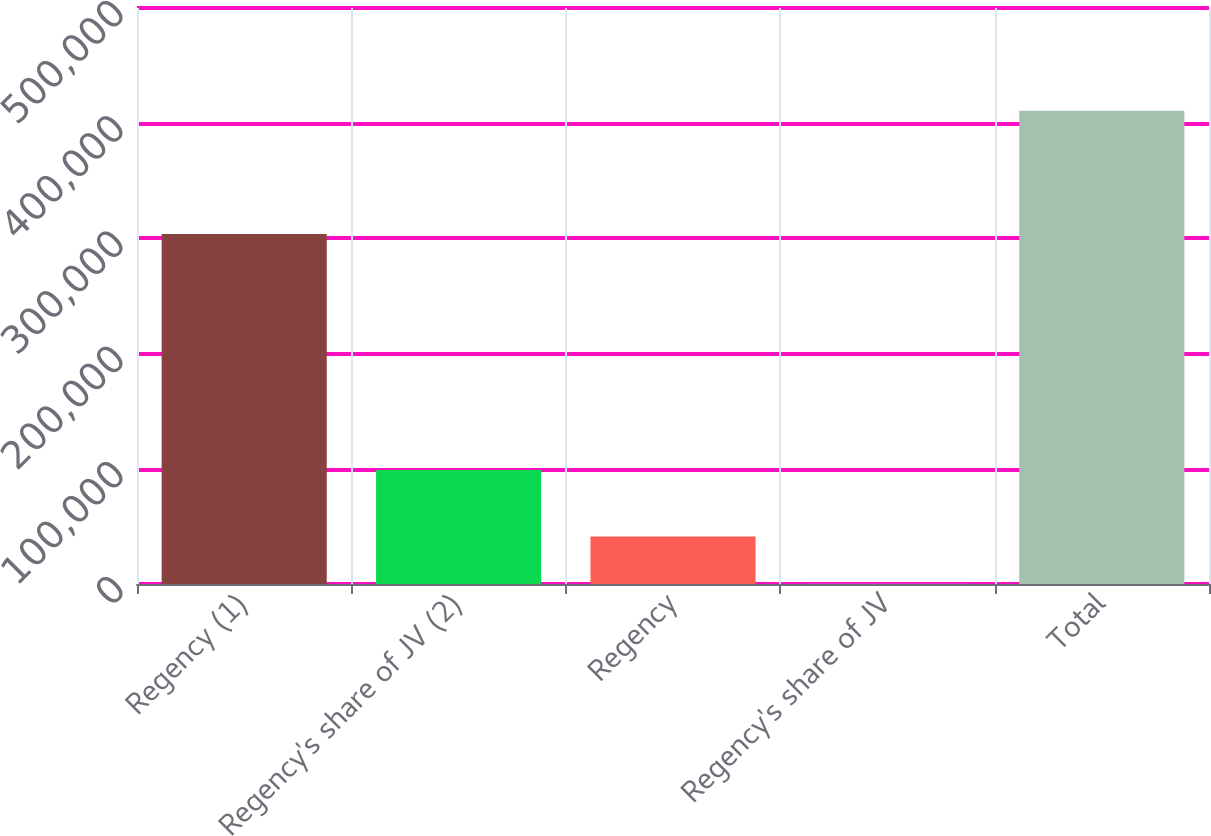Convert chart to OTSL. <chart><loc_0><loc_0><loc_500><loc_500><bar_chart><fcel>Regency (1)<fcel>Regency's share of JV (2)<fcel>Regency<fcel>Regency's share of JV<fcel>Total<nl><fcel>303736<fcel>98977<fcel>41310<fcel>264<fcel>410724<nl></chart> 